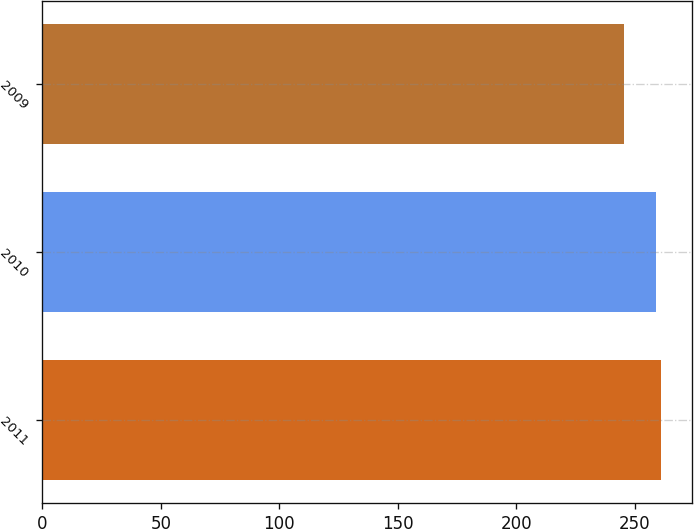<chart> <loc_0><loc_0><loc_500><loc_500><bar_chart><fcel>2011<fcel>2010<fcel>2009<nl><fcel>261.1<fcel>259.1<fcel>245.5<nl></chart> 